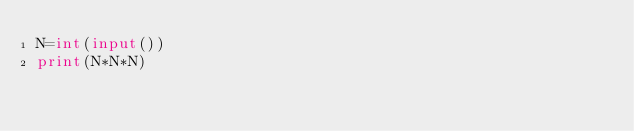<code> <loc_0><loc_0><loc_500><loc_500><_Python_>N=int(input())
print(N*N*N)</code> 